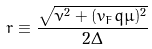<formula> <loc_0><loc_0><loc_500><loc_500>r \equiv \frac { \sqrt { \nu ^ { 2 } + ( v _ { F } q \mu ) ^ { 2 } } } { 2 \Delta }</formula> 